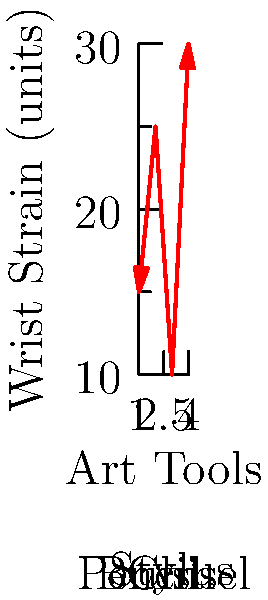Based on the graph showing wrist strain for different art tools, which tool appears to cause the least strain on the wrist during extended use? To determine which art tool causes the least wrist strain, we need to analyze the graph:

1. The x-axis represents different art tools: Pencil (1), Brush (2), Stylus (3), and Chisel (4).
2. The y-axis represents wrist strain in arbitrary units.
3. We need to find the lowest point on the graph, which corresponds to the least strain.

Examining the data points:
- Pencil (1): approximately 15 units of strain
- Brush (2): approximately 25 units of strain
- Stylus (3): approximately 10 units of strain
- Chisel (4): approximately 30 units of strain

The lowest point on the graph corresponds to the Stylus (3), with approximately 10 units of strain.

Therefore, based on this graph, the stylus appears to cause the least strain on the wrist during extended use.
Answer: Stylus 